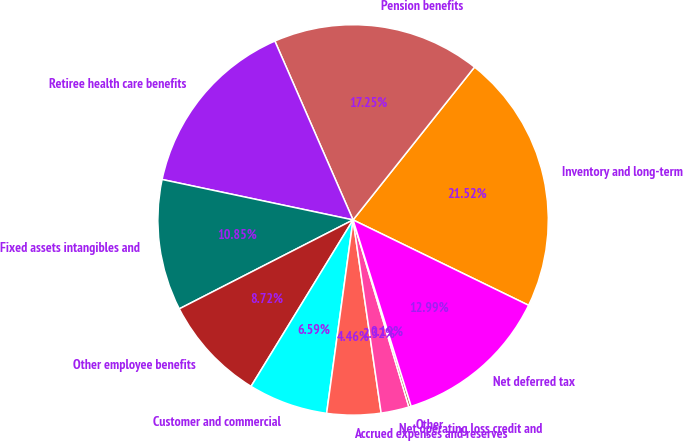<chart> <loc_0><loc_0><loc_500><loc_500><pie_chart><fcel>Inventory and long-term<fcel>Pension benefits<fcel>Retiree health care benefits<fcel>Fixed assets intangibles and<fcel>Other employee benefits<fcel>Customer and commercial<fcel>Accrued expenses and reserves<fcel>Net operating loss credit and<fcel>Other<fcel>Net deferred tax<nl><fcel>21.52%<fcel>17.25%<fcel>15.12%<fcel>10.85%<fcel>8.72%<fcel>6.59%<fcel>4.46%<fcel>2.32%<fcel>0.19%<fcel>12.99%<nl></chart> 